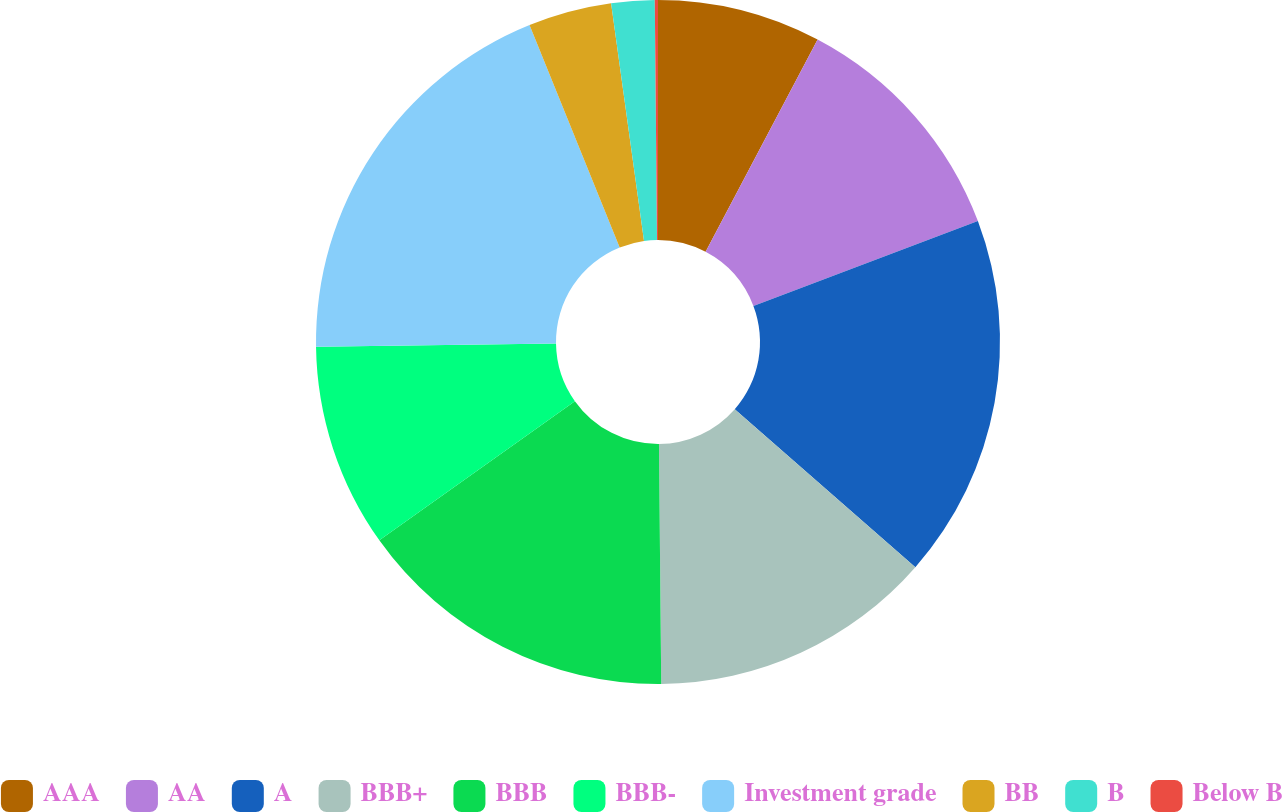Convert chart. <chart><loc_0><loc_0><loc_500><loc_500><pie_chart><fcel>AAA<fcel>AA<fcel>A<fcel>BBB+<fcel>BBB<fcel>BBB-<fcel>Investment grade<fcel>BB<fcel>B<fcel>Below B<nl><fcel>7.73%<fcel>11.52%<fcel>17.2%<fcel>13.41%<fcel>15.31%<fcel>9.62%<fcel>19.1%<fcel>3.94%<fcel>2.04%<fcel>0.15%<nl></chart> 